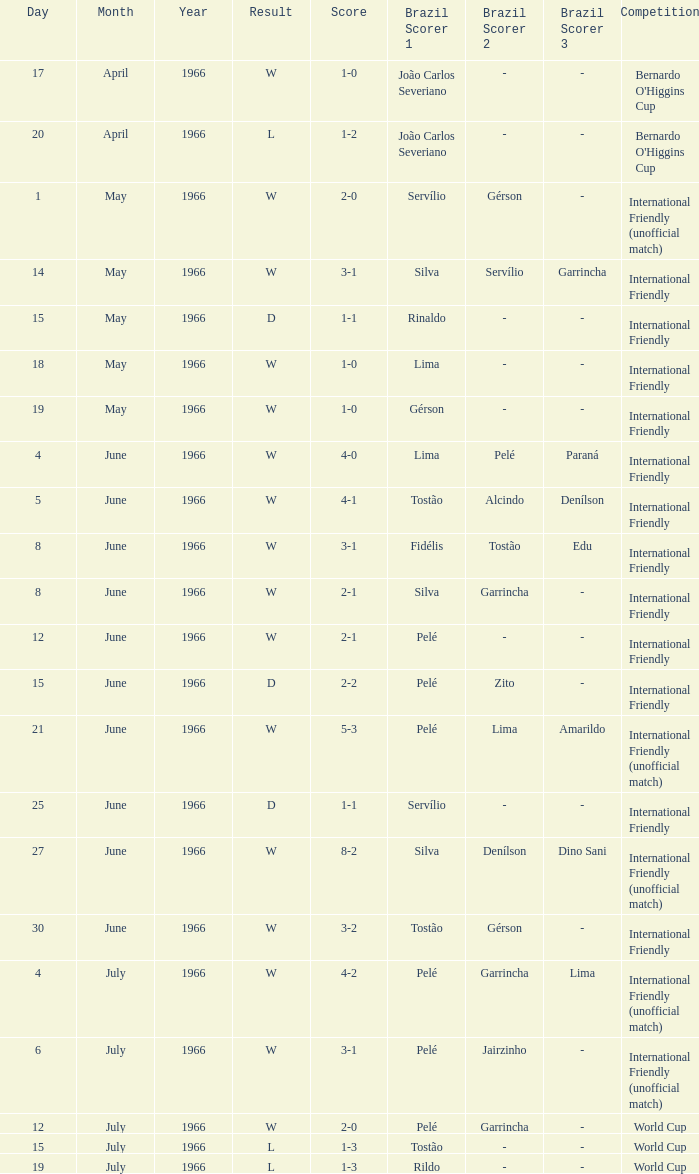In which competitive event was the outcome w on june 30, 1966? International Friendly. 